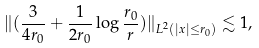Convert formula to latex. <formula><loc_0><loc_0><loc_500><loc_500>\| ( \frac { 3 } { 4 r _ { 0 } } + \frac { 1 } { 2 r _ { 0 } } \log \frac { r _ { 0 } } { r } ) \| _ { L ^ { 2 } ( | x | \leq r _ { 0 } ) } \lesssim 1 ,</formula> 